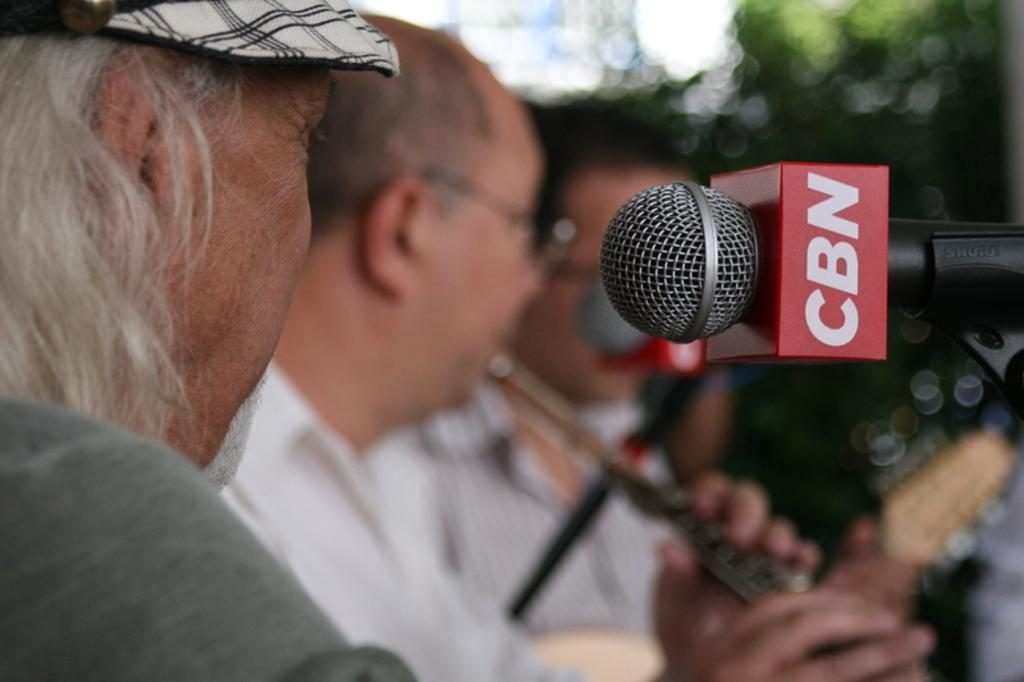What object is located on the right side of the image? There is a microphone on the right side of the image. What can be seen on the microphone? There is text written on the microphone. What is visible on the left side of the image? There are people on the left side of the image. How many trucks are visible in the image? There are no trucks present in the image. What type of spot can be seen on the microphone? There is no spot visible on the microphone; it is not mentioned in the provided facts. 